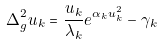<formula> <loc_0><loc_0><loc_500><loc_500>\Delta _ { g } ^ { 2 } u _ { k } = \frac { u _ { k } } { \lambda _ { k } } e ^ { \alpha _ { k } u _ { k } ^ { 2 } } - \gamma _ { k }</formula> 